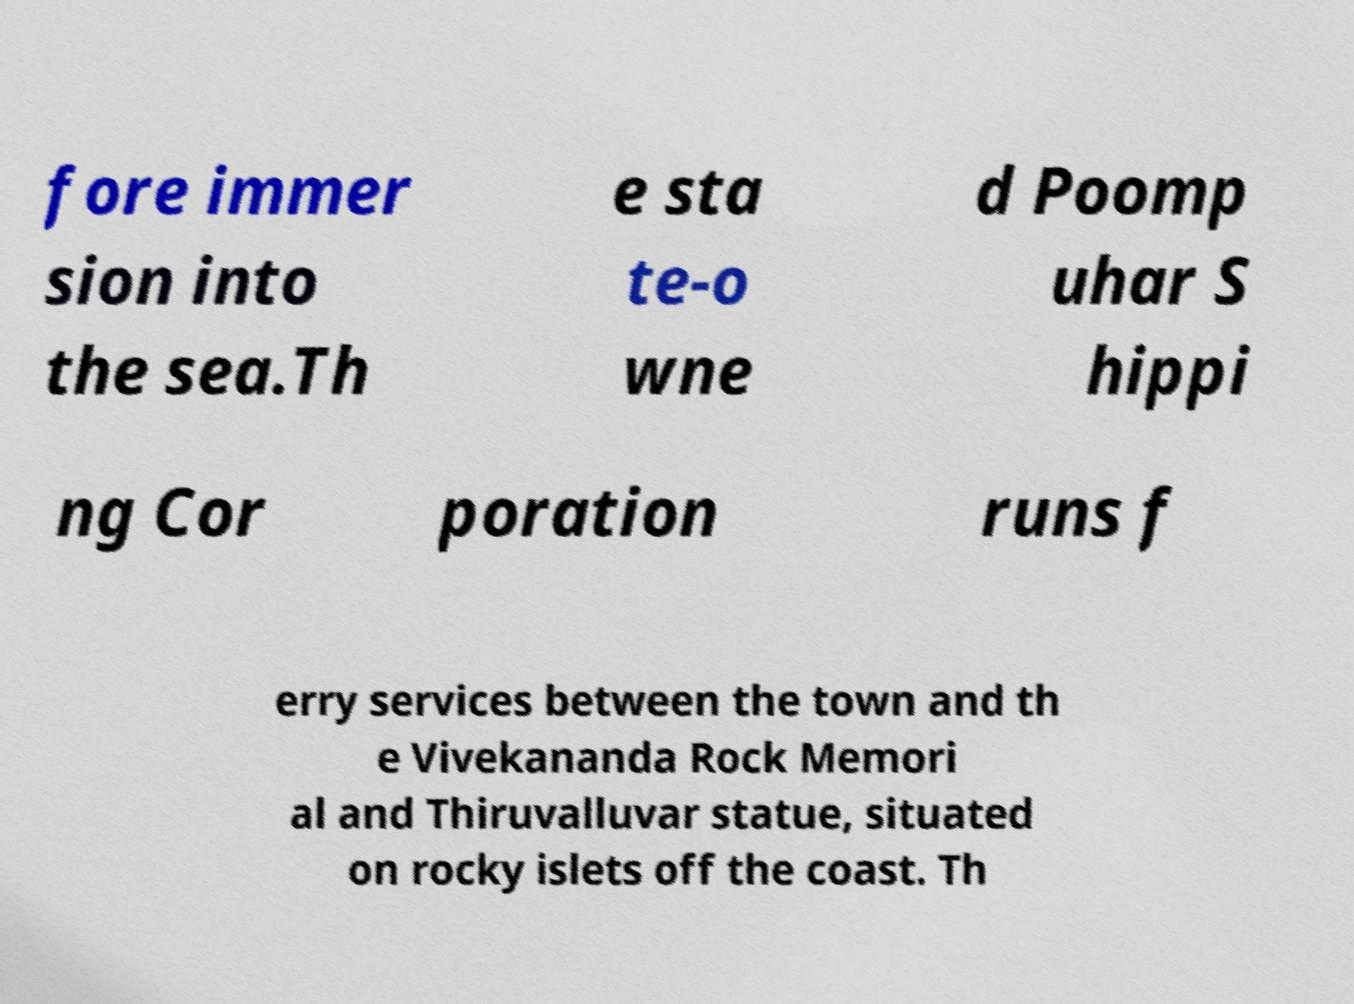For documentation purposes, I need the text within this image transcribed. Could you provide that? fore immer sion into the sea.Th e sta te-o wne d Poomp uhar S hippi ng Cor poration runs f erry services between the town and th e Vivekananda Rock Memori al and Thiruvalluvar statue, situated on rocky islets off the coast. Th 